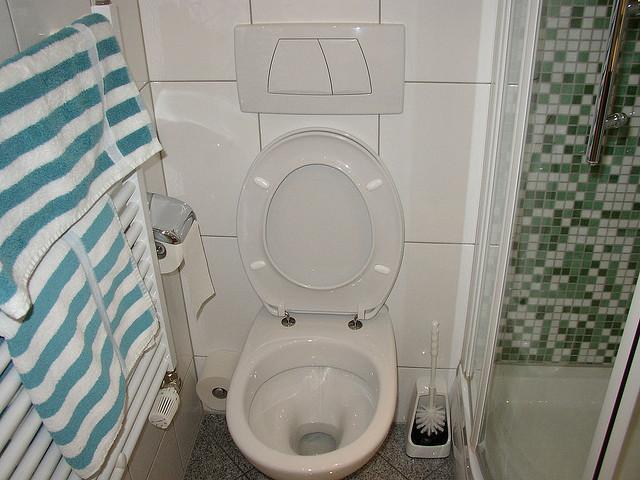How many people are cutting the cake?
Give a very brief answer. 0. 